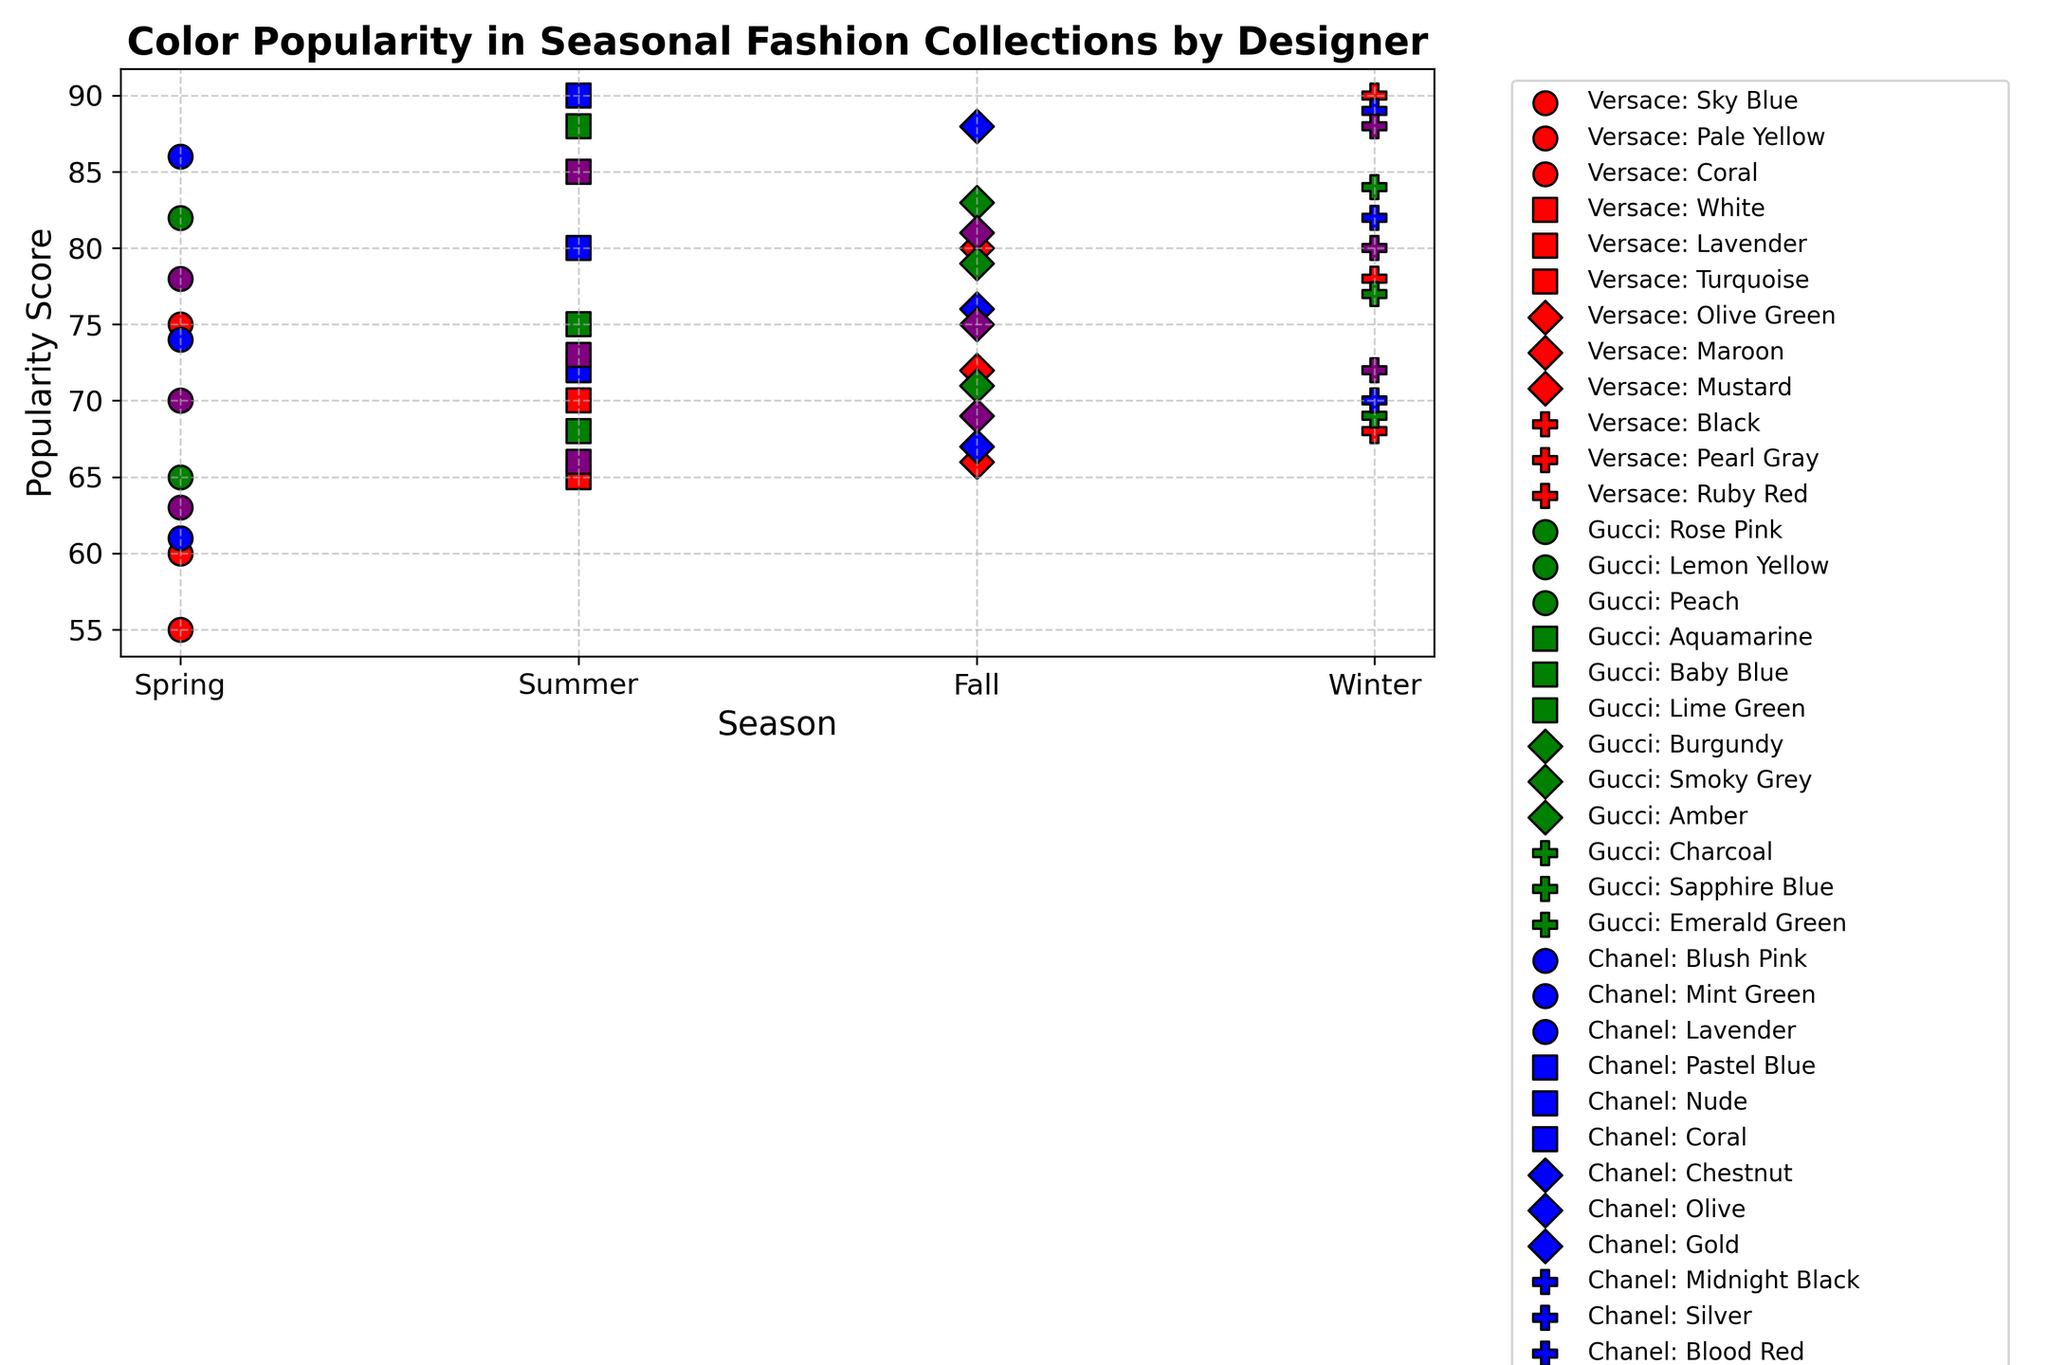Which designer has the most popular color in the Winter season? To identify the most popular color in the Winter season, look for the highest point in the Winter column. This point represents a black marker (Versace) with a score of 90.
Answer: Versace How does the popularity of Coral change across seasons for Versace? For Versace, Coral appears in Spring and Summer. In Spring, Coral has a popularity score of 55, and in Summer, Coral has a popularity score of 72.
Answer: Increases from 55 to 72 What's the average popularity score for Gucci's Spring colors? The Spring colors for Gucci are Rose Pink, Lemon Yellow, and Peach. Their popularity scores are 82, 70, and 65 respectively. The average is (82 + 70 + 65) / 3 = 72.33.
Answer: 72.33 Which season has the highest average popularity score for Chanel? Calculate the average score for each season for Chanel: Spring (86, 74, 61) avg = (86 + 74 + 61) / 3 = 73.67; Summer (90, 80, 72) avg = (90 + 80 + 72) / 3 = 80.67; Fall (88, 76, 67) avg = (88 + 76 + 67) / 3 = 77; Winter (89, 82, 70) avg = (89 + 82 + 70) / 3 = 80.33. Compare these to find the highest.
Answer: Summer How does the color popularity of Sky Blue in Versace compare between Spring and Summer? Sky Blue for Versace is only in the Spring with a score of 75, and it does not appear in the Summer. Hence, there is no comparison.
Answer: Only in Spring Which combination of designer and season has the most consistent (smallest range) color popularity scores? Calculate the range (maximum - minimum) for each designer-season combination. The consistency is measured by the smallest range. For example, Versace Spring: (75, 60, 55) range is 75-55=20; Repeat for all combinations. Alexander McQueen Winter: (88, 80, 72) range is 88-72=16 shows it as the smallest.
Answer: Alexander McQueen Winter Which color has the highest popularity score overall and which designer does it belong to? Identify the highest point in the entire plot. The highest popularity score is 90. It appears in Summer (Pastel Blue, Chanel) and Winter (Black, Versace). Both colors belong to different designers.
Answer: Pastel Blue (Chanel) and Black (Versace) Compare the popularity of Lavender between Versace in Summer and Chanel in Spring. Lavender for Versace in Summer has a popularity score of 70, while Lavender for Chanel in Spring has a popularity score of 61.
Answer: Versace's Lavender is more popular What's the difference in popularity scores of the most popular color in Winter for Gucci and Versace? Identify the most popular colors in Winter for both designers: Versace (Black, 90) and Gucci (Charcoal, 84). The difference is 90 - 84 = 6.
Answer: 6 